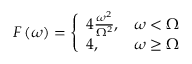Convert formula to latex. <formula><loc_0><loc_0><loc_500><loc_500>F \left ( \omega \right ) = \left \{ \begin{array} { l l } { 4 \frac { \omega ^ { 2 } } { \Omega ^ { 2 } } , } & { \omega < \Omega } \\ { 4 , } & { \omega \geq \Omega } \end{array}</formula> 